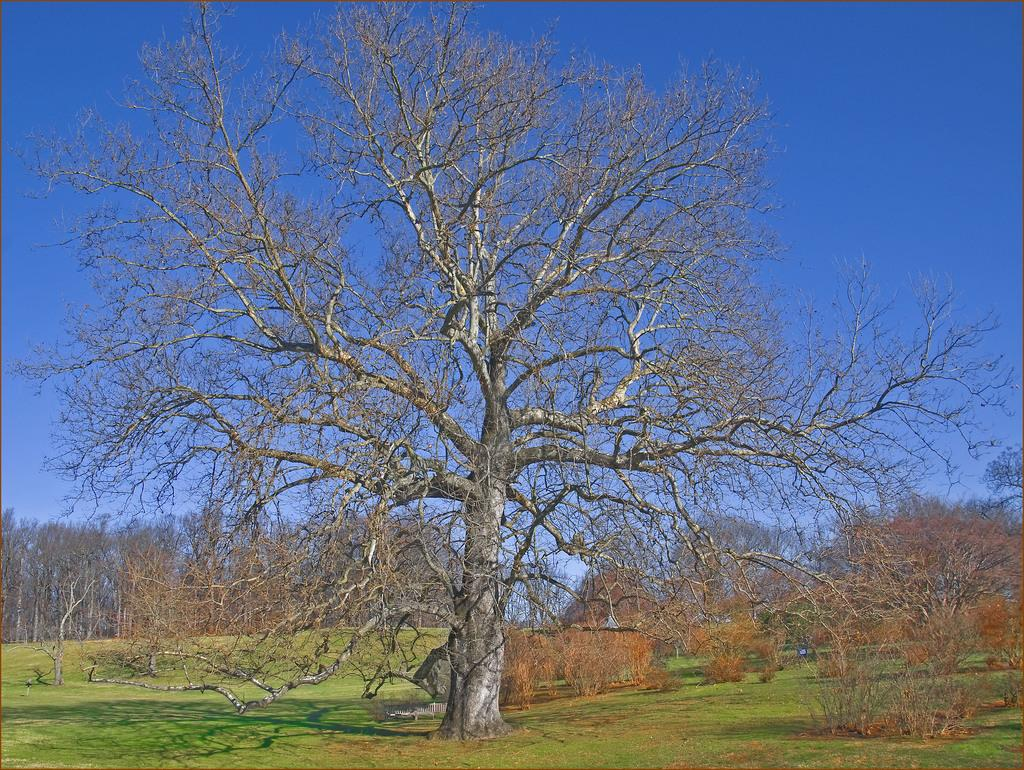What type of vegetation is present in the image? There is grass in the image. What can be seen in the background of the image? There are trees and the sky visible in the background of the image. Reasoning: Let'g: Let's think step by step in order to produce the conversation. We start by identifying the main subject in the image, which is the grass. Then, we expand the conversation to include other elements that are also visible, such as the trees and the sky in the background. Each question is designed to elicit a specific detail about the image that is known from the provided facts. Absurd Question/Answer: What type of mark can be seen on the alley in the image? There is no alley present in the image; it features grass, trees, and the sky. What type of crack can be seen on the crib in the image? There is no crib present in the image; it features grass, trees, and the sky. 